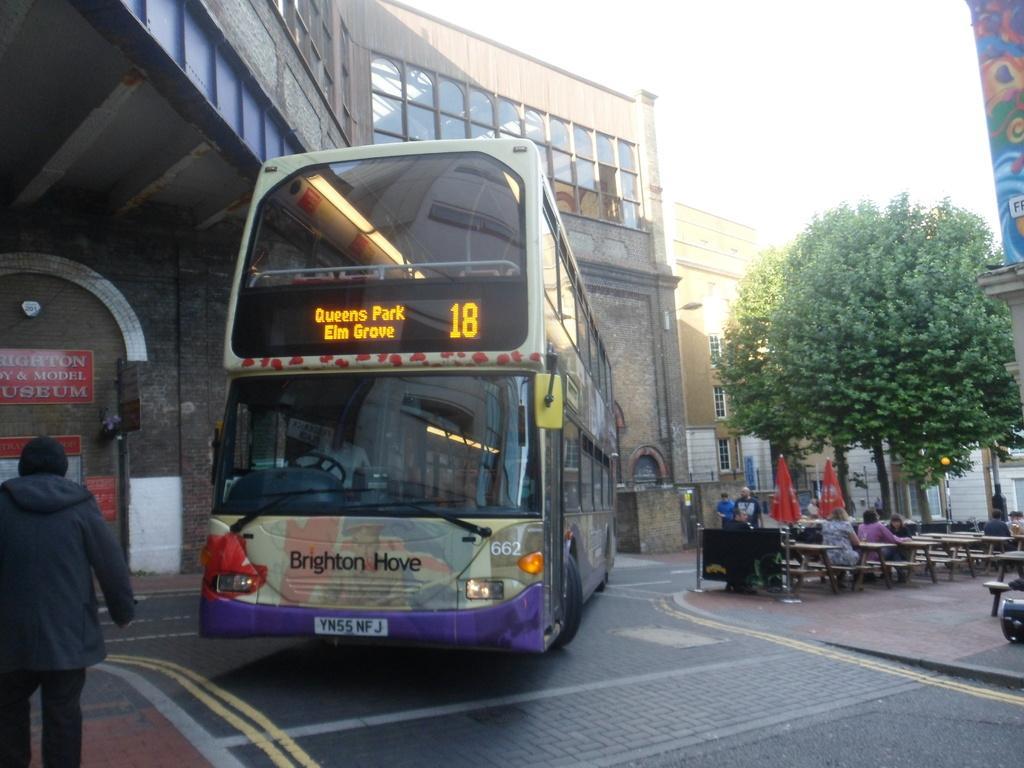How would you summarize this image in a sentence or two? In this picture we can see a bus on the road, benches, umbrellas, tree, banner, buildings with windows and some people and in the background we can see the sky. 